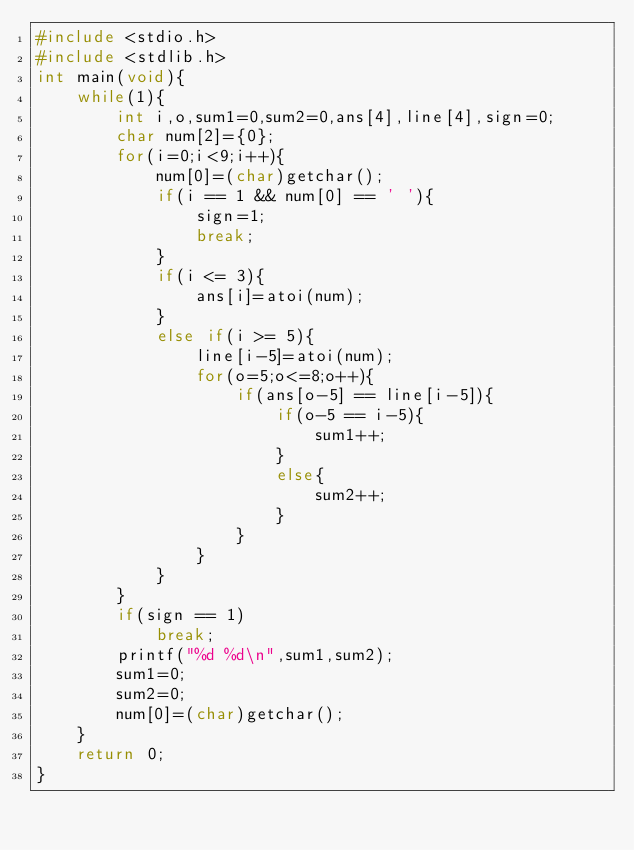<code> <loc_0><loc_0><loc_500><loc_500><_C_>#include <stdio.h>
#include <stdlib.h>
int main(void){
    while(1){
        int i,o,sum1=0,sum2=0,ans[4],line[4],sign=0;
        char num[2]={0};
        for(i=0;i<9;i++){
            num[0]=(char)getchar();
            if(i == 1 && num[0] == ' '){
                sign=1;
                break;
            }
            if(i <= 3){
                ans[i]=atoi(num);
            }
            else if(i >= 5){
                line[i-5]=atoi(num);
                for(o=5;o<=8;o++){
                    if(ans[o-5] == line[i-5]){
                        if(o-5 == i-5){
                            sum1++;
                        }
                        else{
                            sum2++;
                        }
                    }
                }
            }
        }
        if(sign == 1)
            break;
        printf("%d %d\n",sum1,sum2);
        sum1=0;
        sum2=0;
        num[0]=(char)getchar();
    }
    return 0;
}</code> 